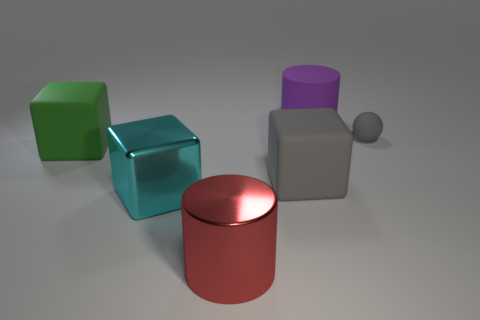Subtract all large green matte blocks. How many blocks are left? 2 Add 3 big purple cylinders. How many objects exist? 9 Subtract all red cylinders. How many cylinders are left? 1 Subtract all spheres. How many objects are left? 5 Subtract 1 cylinders. How many cylinders are left? 1 Subtract all purple cylinders. How many green cubes are left? 1 Subtract all large purple rubber things. Subtract all green objects. How many objects are left? 4 Add 3 purple rubber cylinders. How many purple rubber cylinders are left? 4 Add 5 red matte things. How many red matte things exist? 5 Subtract 0 cyan cylinders. How many objects are left? 6 